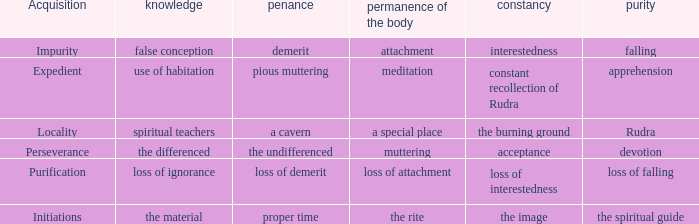What is the unchangeability in which the lastingness of the body is meditation? Constant recollection of rudra. 